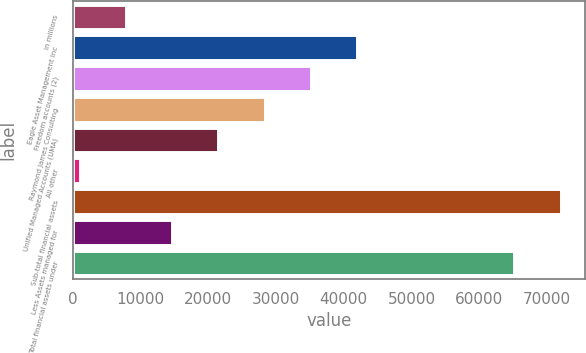<chart> <loc_0><loc_0><loc_500><loc_500><bar_chart><fcel>in millions<fcel>Eagle Asset Management Inc<fcel>Freedom accounts (2)<fcel>Raymond James Consulting<fcel>Unified Managed Accounts (UMA)<fcel>All other<fcel>Sub-total financial assets<fcel>Less Assets managed for<fcel>Total financial assets under<nl><fcel>7913.7<fcel>41902.2<fcel>35104.5<fcel>28306.8<fcel>21509.1<fcel>1116<fcel>71974.7<fcel>14711.4<fcel>65177<nl></chart> 